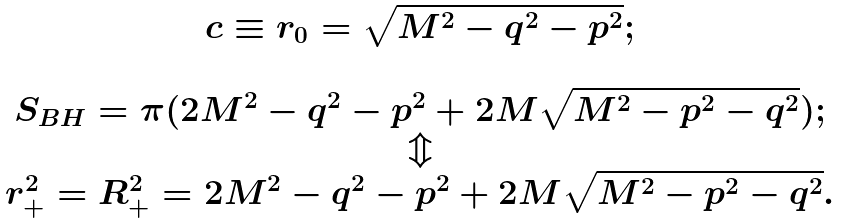<formula> <loc_0><loc_0><loc_500><loc_500>\begin{array} { c } c \equiv r _ { 0 } = \sqrt { M ^ { 2 } - q ^ { 2 } - p ^ { 2 } } ; \\ \\ S _ { B H } = \pi ( 2 M ^ { 2 } - q ^ { 2 } - p ^ { 2 } + 2 M \sqrt { M ^ { 2 } - p ^ { 2 } - q ^ { 2 } } ) ; \\ \Updownarrow \\ r _ { + } ^ { 2 } = R _ { + } ^ { 2 } = 2 M ^ { 2 } - q ^ { 2 } - p ^ { 2 } + 2 M \sqrt { M ^ { 2 } - p ^ { 2 } - q ^ { 2 } } . \end{array}</formula> 